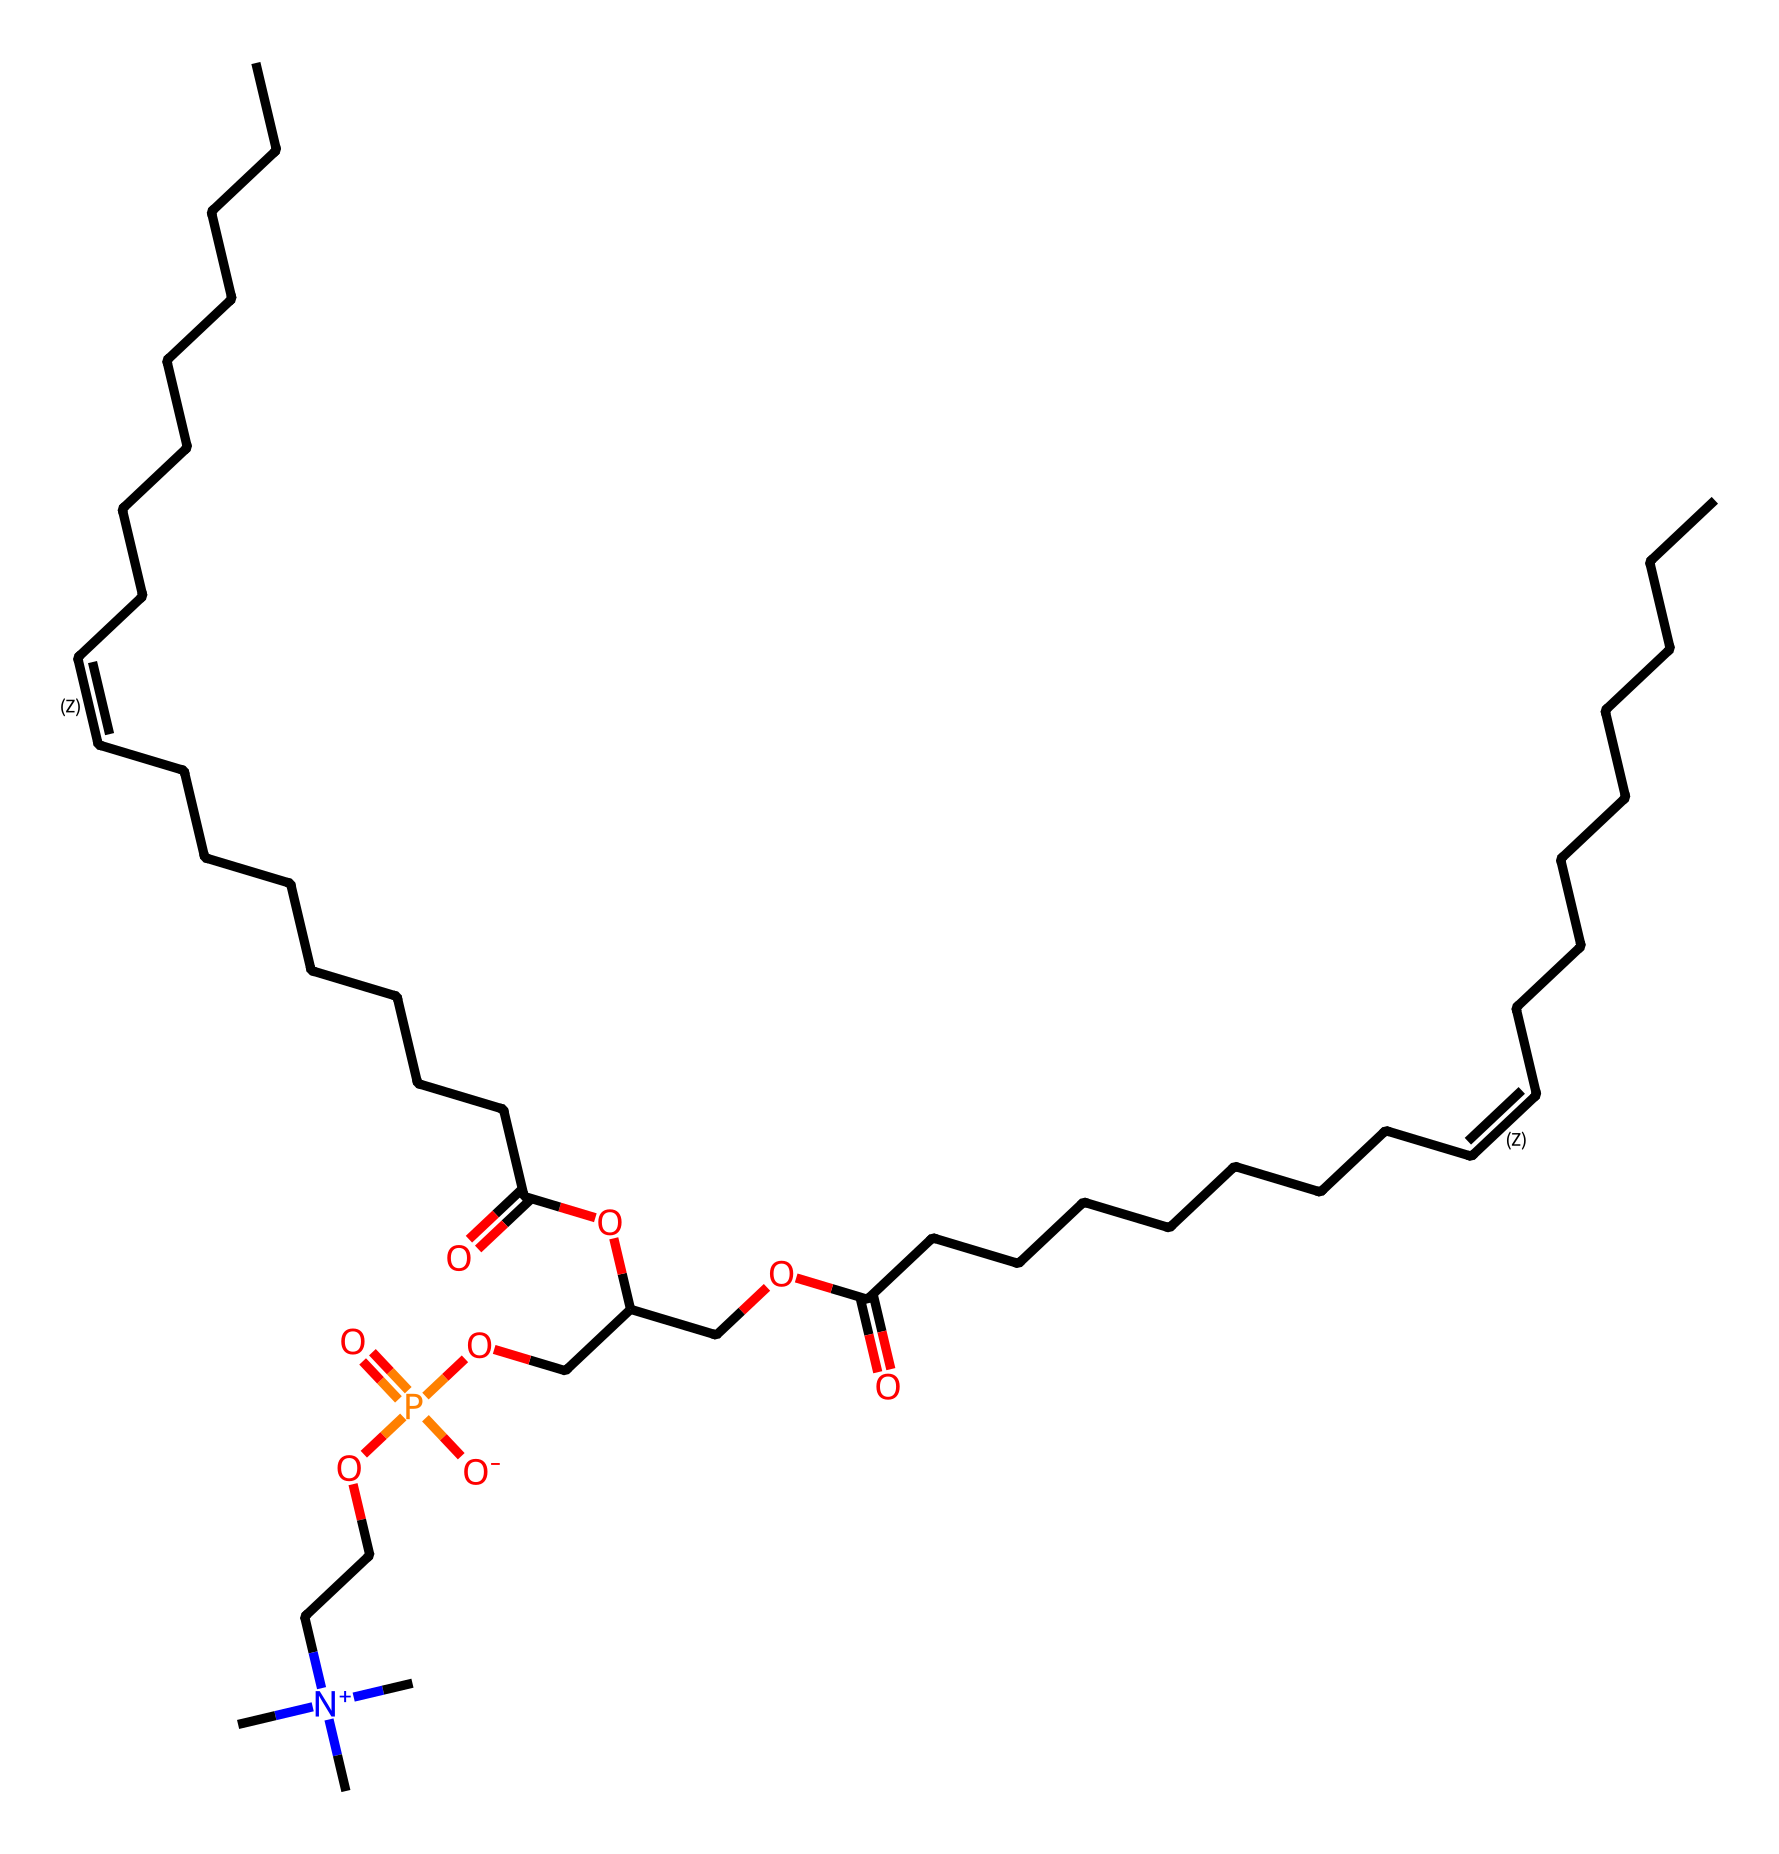What is the molecular formula of lecithin? To determine the molecular formula, we need to analyze the SMILES representation. The structure consists of carbon (C), hydrogen (H), oxygen (O), and phosphorus (P) atoms. Counting the atoms from the SMILES indicates the numbers of C, H, O, and P in the formula.
Answer: C 42 H 83 N 2 O 10 P How many double bonds are present in lecithin? By examining the SMILES, we can identify the double bonds from the 'C=C' segments. There are two instances of 'C=C' in the structure, indicating the presence of two double bonds.
Answer: 2 What functional groups are present in lecithin? The functional groups can be identified by looking for specific arrangements in the SMILES, such as carboxylic acids (C(=O)O), phosphoesters (P(=O)([O-])), and amines (indicated by nitrogen). Lecithin contains a carboxyl group and a phosphate group as its functional groups.
Answer: carboxylic acid and phosphate How many carbon atoms are in lecithin? To find the number of carbon atoms, we count every 'C' in the SMILES structure. Additionally, since we know carbon can exist in chains, we include every carbon atom represented. The total is 42 carbons.
Answer: 42 What role does lecithin play as a surfactant? Lecithin acts as a surfactant by reducing surface tension due to its amphiphilic structure with a hydrophilic head (phosphate group) and hydrophobic tail (long carbon chains). This property allows it to help mix water with oils.
Answer: reduces surface tension 